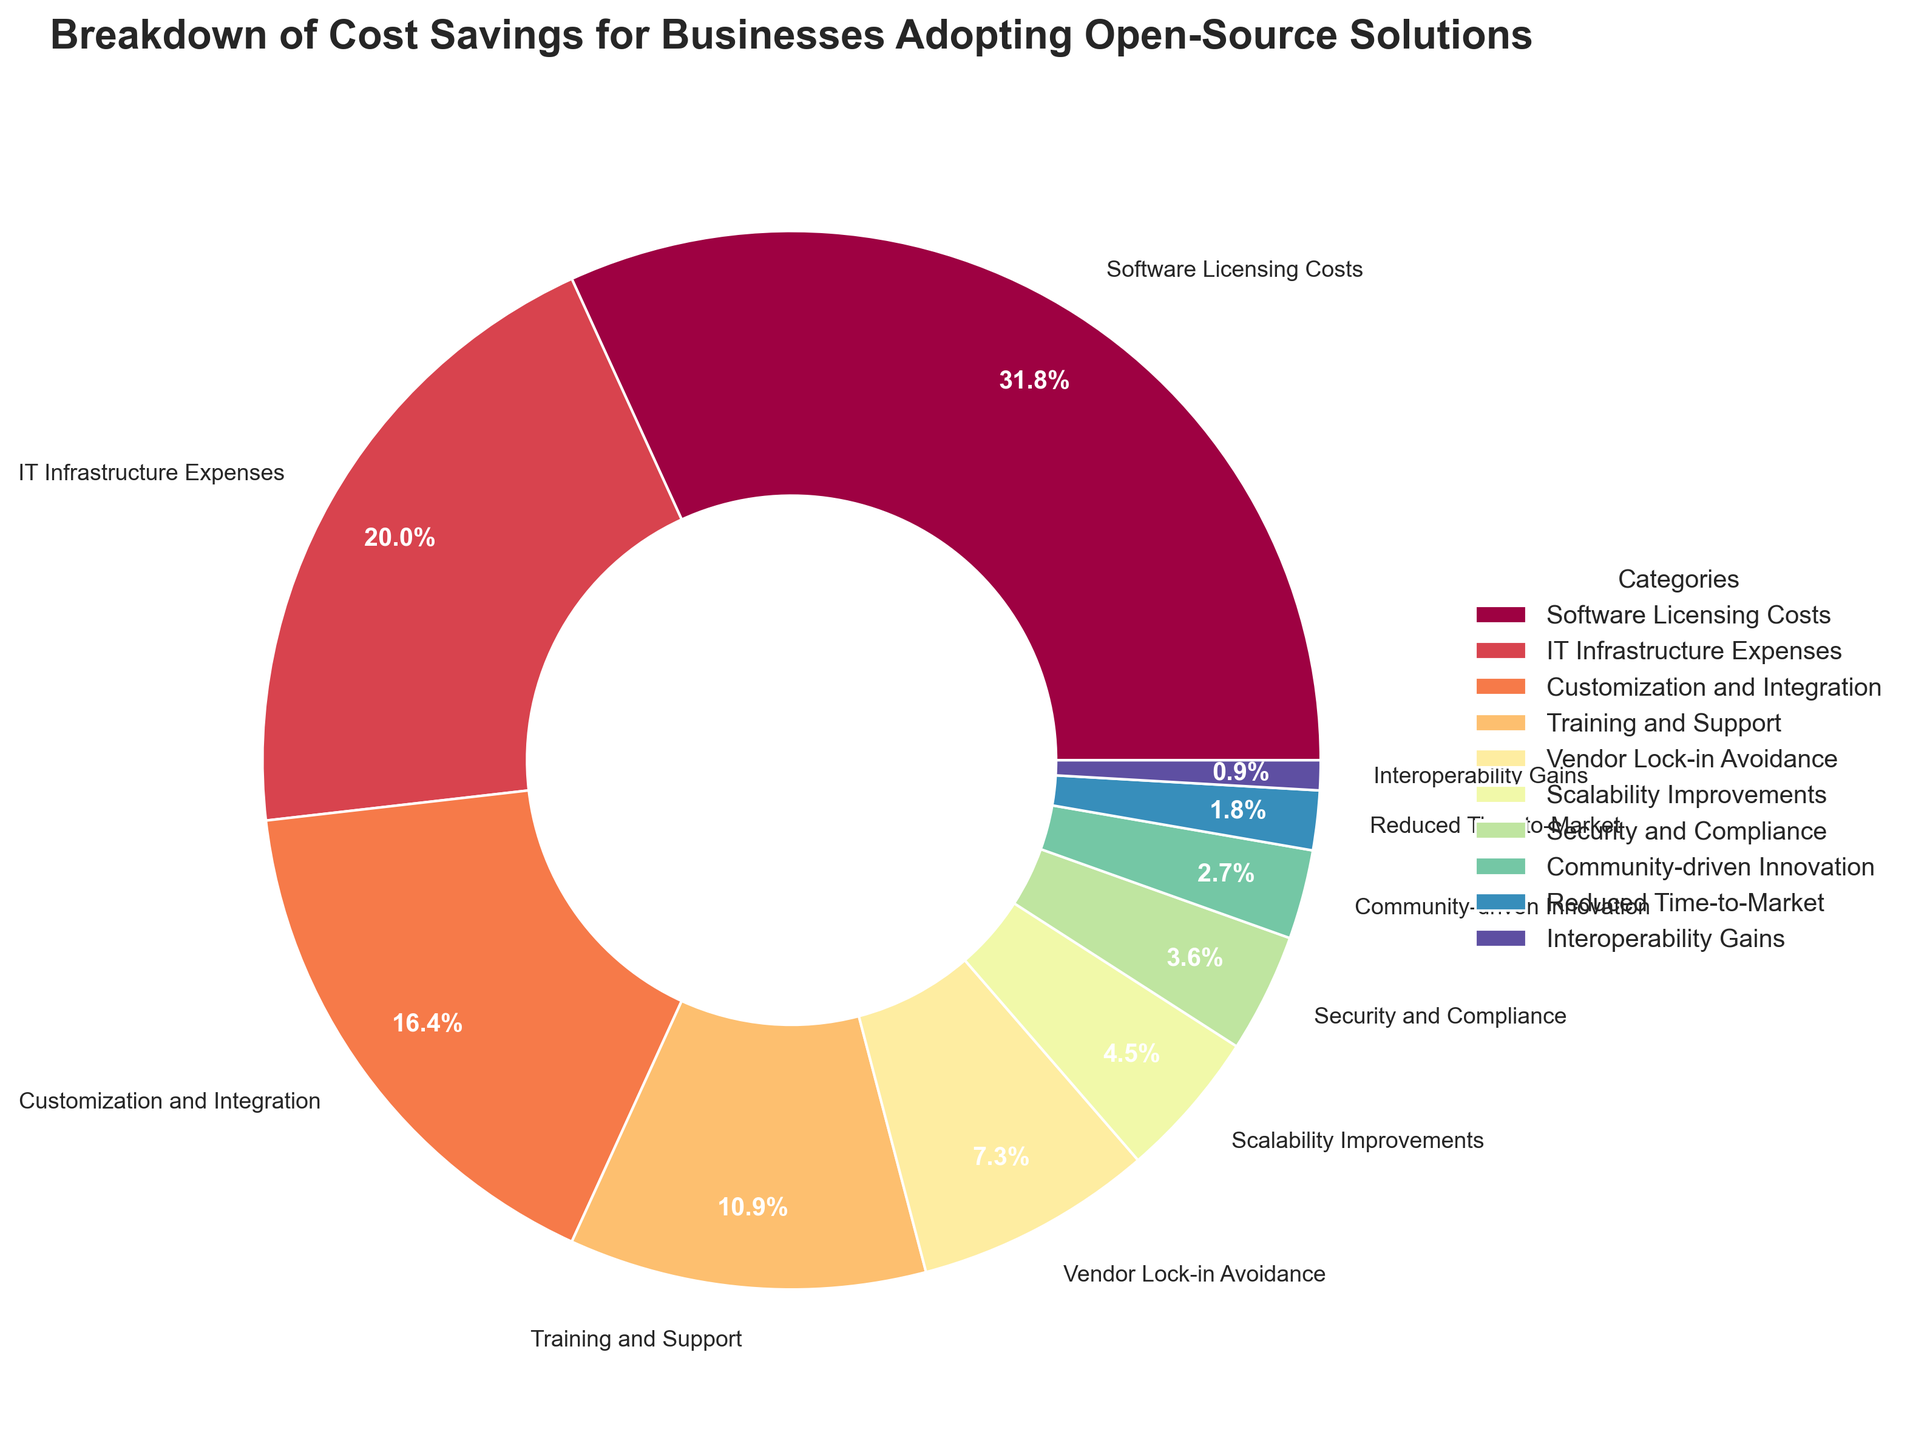Which category accounts for the largest portion of cost savings? By examining the figure, the largest segment corresponds to 'Software Licensing Costs', which has a percentage label of 35%.
Answer: Software Licensing Costs What is the combined percentage of cost savings from 'IT Infrastructure Expenses' and 'Customization and Integration'? 'IT Infrastructure Expenses' account for 22%, and 'Customization and Integration' account for 18%. Adding these percentages: 22% + 18% = 40%.
Answer: 40% Which category is associated with the smallest portion of cost savings, and what is its percentage? The smallest segment is labeled as 'Interoperability Gains', which accounts for 1% of the total cost savings.
Answer: Interoperability Gains, 1% How much more percentage does 'Training and Support' account for compared to 'Vendor Lock-in Avoidance'? 'Training and Support' accounts for 12%, and 'Vendor Lock-in Avoidance' accounts for 8%. The difference is 12% - 8% = 4%.
Answer: 4% Is the percentage for 'Scalability Improvements' greater than or less than that for 'Security and Compliance'? 'Scalability Improvements' account for 5%, and 'Security and Compliance' account for 4%. Therefore, 'Scalability Improvements' is greater by 1%.
Answer: Greater What percentage of cost savings is not covered by the top three categories? The top three categories are 'Software Licensing Costs' (35%), 'IT Infrastructure Expenses' (22%), and 'Customization and Integration' (18%). Combined, they account for 35% + 22% + 18% = 75%. The remaining percentage is 100% - 75% = 25%.
Answer: 25% Which categories collectively account for exactly one-third of the total cost savings? The total cost savings is 100%, one-third of that is approximately 33.33%. Combining 'Customization and Integration' (18%), 'Training and Support' (12%), and 'Vendor Lock-in Avoidance' (8%) equals 18% + 12% + 8% = 38%, which is close but not exact. 'IT Infrastructure Expenses' (22%) and 'Training and Support' (12%) equal 22% + 12% = 34%, which is very close to one-third.
Answer: IT Infrastructure Expenses and Training and Support What is the difference in percentage between the cost savings from 'Community-driven Innovation' and 'Scaled Improvements'? 'Community-driven Innovation' accounts for 3%, and 'Scalability Improvements' account for 5%. The difference is 5% - 3% = 2%.
Answer: 2% If 'Vendor Lock-in Avoidance' and 'Security and Compliance' are grouped, what would be their combined percentage? 'Vendor Lock-in Avoidance' accounts for 8%, and 'Security and Compliance' account for 4%. Their combined percentage is 8% + 4% = 12%.
Answer: 12% Which category shows a percentage close to the combined percentage of 'Reduced Time-to-Market' and 'Interoperability Gains'? 'Reduced Time-to-Market' (2%) combined with 'Interoperability Gains' (1%) results in 2% + 1% = 3%. The category that shows a percentage close to 3% is 'Community-driven Innovation', which also accounts for 3%.
Answer: Community-driven Innovation 